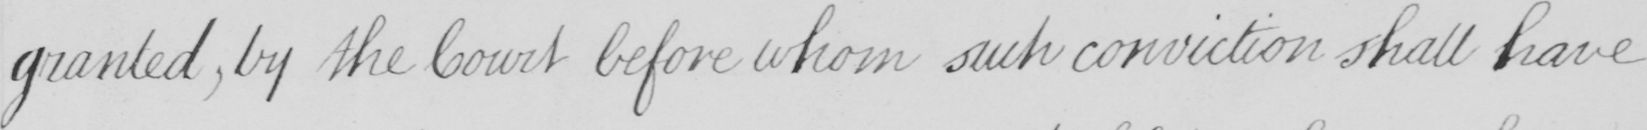Transcribe the text shown in this historical manuscript line. granted , by the Court before whom such conviction shall have 